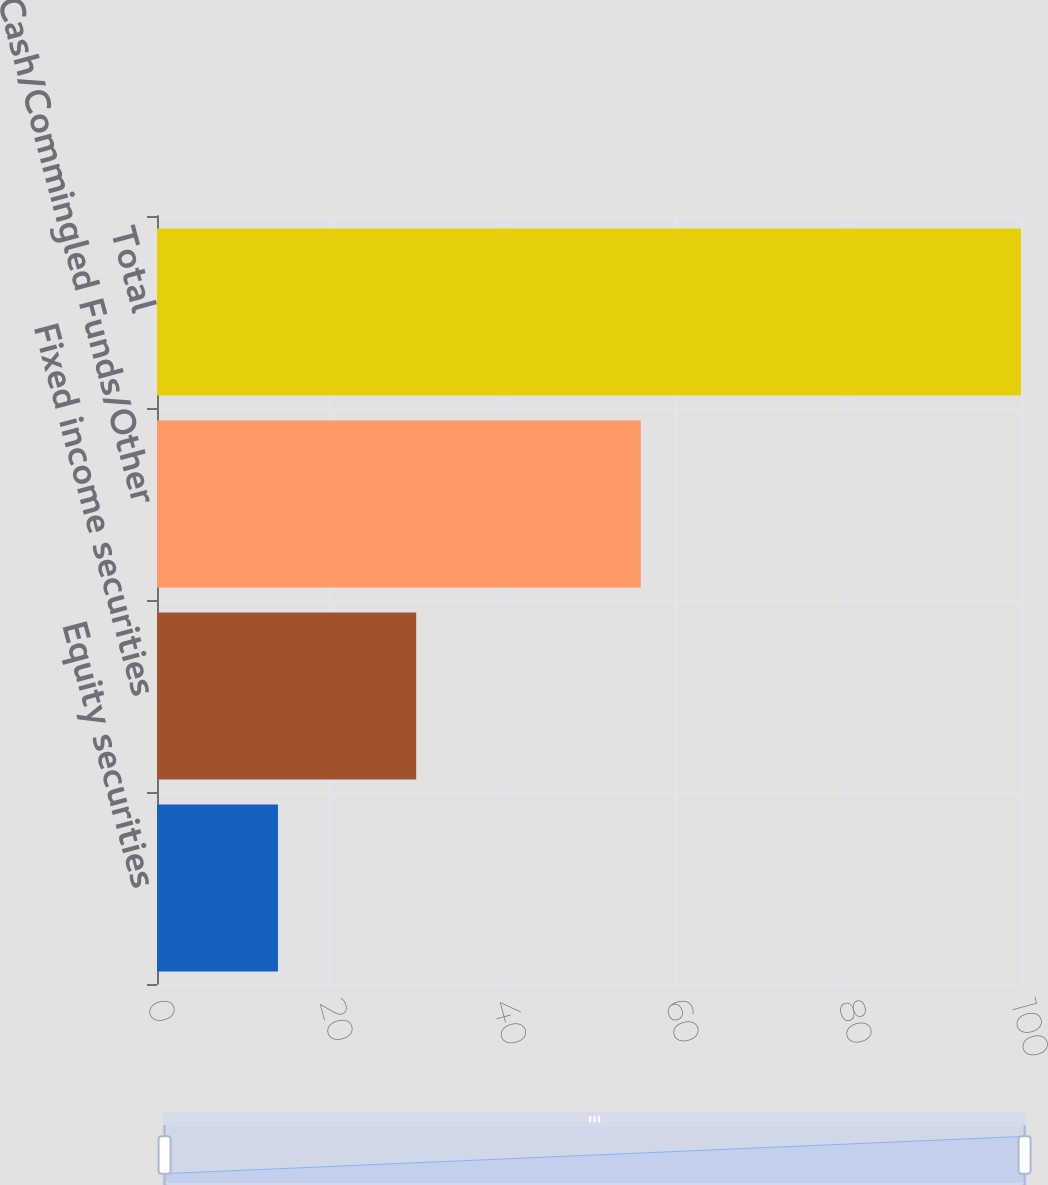Convert chart to OTSL. <chart><loc_0><loc_0><loc_500><loc_500><bar_chart><fcel>Equity securities<fcel>Fixed income securities<fcel>Cash/Commingled Funds/Other<fcel>Total<nl><fcel>14<fcel>30<fcel>56<fcel>100<nl></chart> 